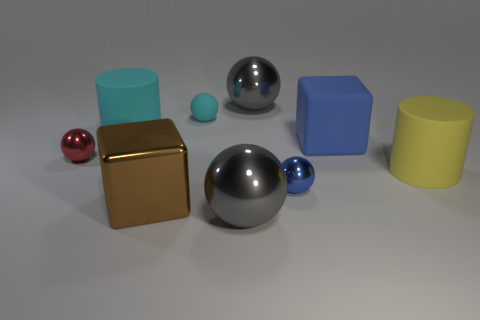The other big thing that is the same shape as the big brown thing is what color?
Keep it short and to the point. Blue. There is a tiny metal ball left of the large brown shiny object; does it have the same color as the ball that is behind the tiny cyan object?
Ensure brevity in your answer.  No. Is the number of blue metallic balls behind the yellow cylinder greater than the number of big brown metal cylinders?
Your answer should be very brief. No. How many other things are the same size as the blue metal object?
Your answer should be compact. 2. What number of metal things are both behind the yellow matte cylinder and in front of the red metallic sphere?
Your answer should be very brief. 0. Do the big sphere that is behind the large blue block and the red object have the same material?
Your answer should be compact. Yes. There is a tiny metal thing that is to the right of the gray ball that is behind the small ball behind the blue cube; what shape is it?
Your answer should be very brief. Sphere. Are there an equal number of blue matte cubes to the left of the large cyan object and blue metallic things right of the blue rubber object?
Keep it short and to the point. Yes. The rubber block that is the same size as the metallic block is what color?
Provide a short and direct response. Blue. What number of small things are red metallic balls or blue matte blocks?
Keep it short and to the point. 1. 